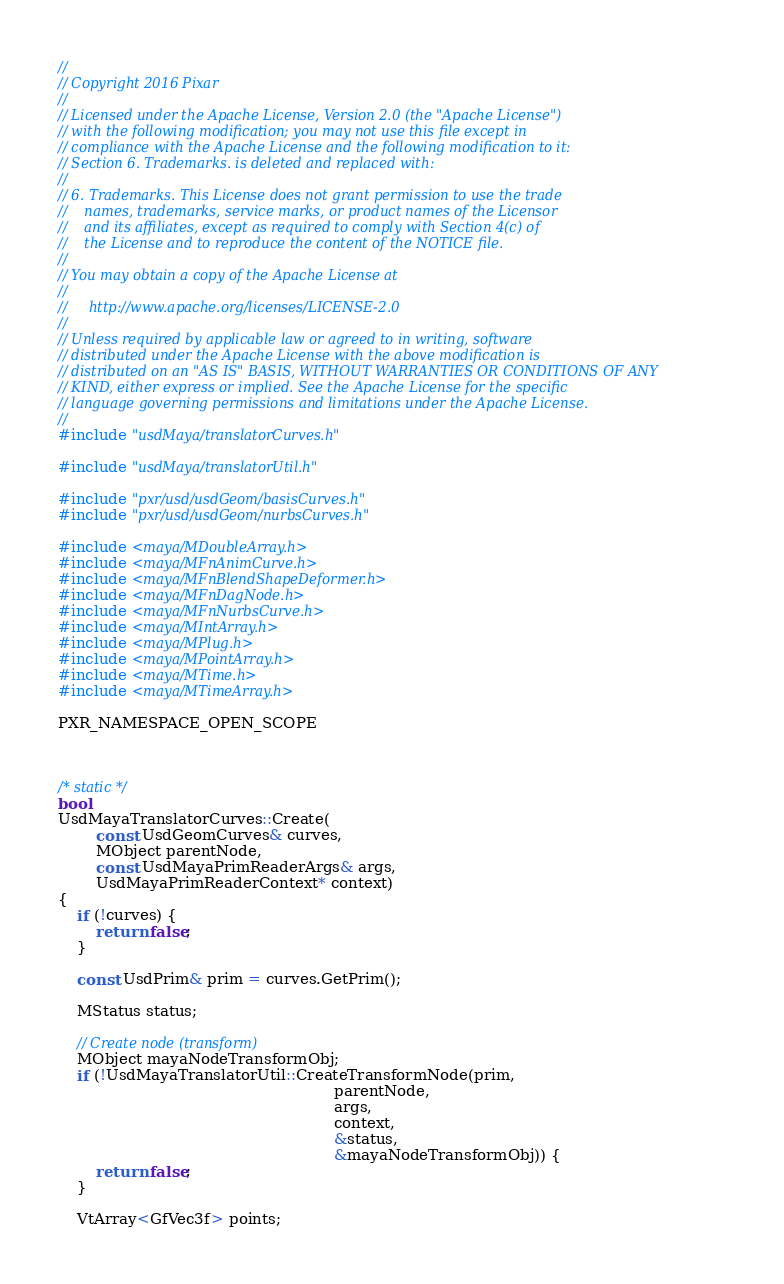Convert code to text. <code><loc_0><loc_0><loc_500><loc_500><_C++_>//
// Copyright 2016 Pixar
//
// Licensed under the Apache License, Version 2.0 (the "Apache License")
// with the following modification; you may not use this file except in
// compliance with the Apache License and the following modification to it:
// Section 6. Trademarks. is deleted and replaced with:
//
// 6. Trademarks. This License does not grant permission to use the trade
//    names, trademarks, service marks, or product names of the Licensor
//    and its affiliates, except as required to comply with Section 4(c) of
//    the License and to reproduce the content of the NOTICE file.
//
// You may obtain a copy of the Apache License at
//
//     http://www.apache.org/licenses/LICENSE-2.0
//
// Unless required by applicable law or agreed to in writing, software
// distributed under the Apache License with the above modification is
// distributed on an "AS IS" BASIS, WITHOUT WARRANTIES OR CONDITIONS OF ANY
// KIND, either express or implied. See the Apache License for the specific
// language governing permissions and limitations under the Apache License.
//
#include "usdMaya/translatorCurves.h"

#include "usdMaya/translatorUtil.h"

#include "pxr/usd/usdGeom/basisCurves.h"
#include "pxr/usd/usdGeom/nurbsCurves.h"

#include <maya/MDoubleArray.h>
#include <maya/MFnAnimCurve.h>
#include <maya/MFnBlendShapeDeformer.h>
#include <maya/MFnDagNode.h>
#include <maya/MFnNurbsCurve.h>
#include <maya/MIntArray.h>
#include <maya/MPlug.h>
#include <maya/MPointArray.h>
#include <maya/MTime.h>
#include <maya/MTimeArray.h>

PXR_NAMESPACE_OPEN_SCOPE



/* static */
bool
UsdMayaTranslatorCurves::Create(
        const UsdGeomCurves& curves,
        MObject parentNode,
        const UsdMayaPrimReaderArgs& args,
        UsdMayaPrimReaderContext* context)
{
    if (!curves) {
        return false;
    }

    const UsdPrim& prim = curves.GetPrim();

    MStatus status;

    // Create node (transform)
    MObject mayaNodeTransformObj;
    if (!UsdMayaTranslatorUtil::CreateTransformNode(prim,
                                                          parentNode,
                                                          args,
                                                          context,
                                                          &status,
                                                          &mayaNodeTransformObj)) {
        return false;
    }

    VtArray<GfVec3f> points;</code> 